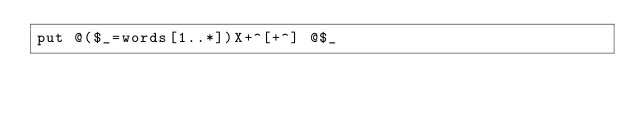<code> <loc_0><loc_0><loc_500><loc_500><_Perl_>put @($_=words[1..*])X+^[+^] @$_</code> 